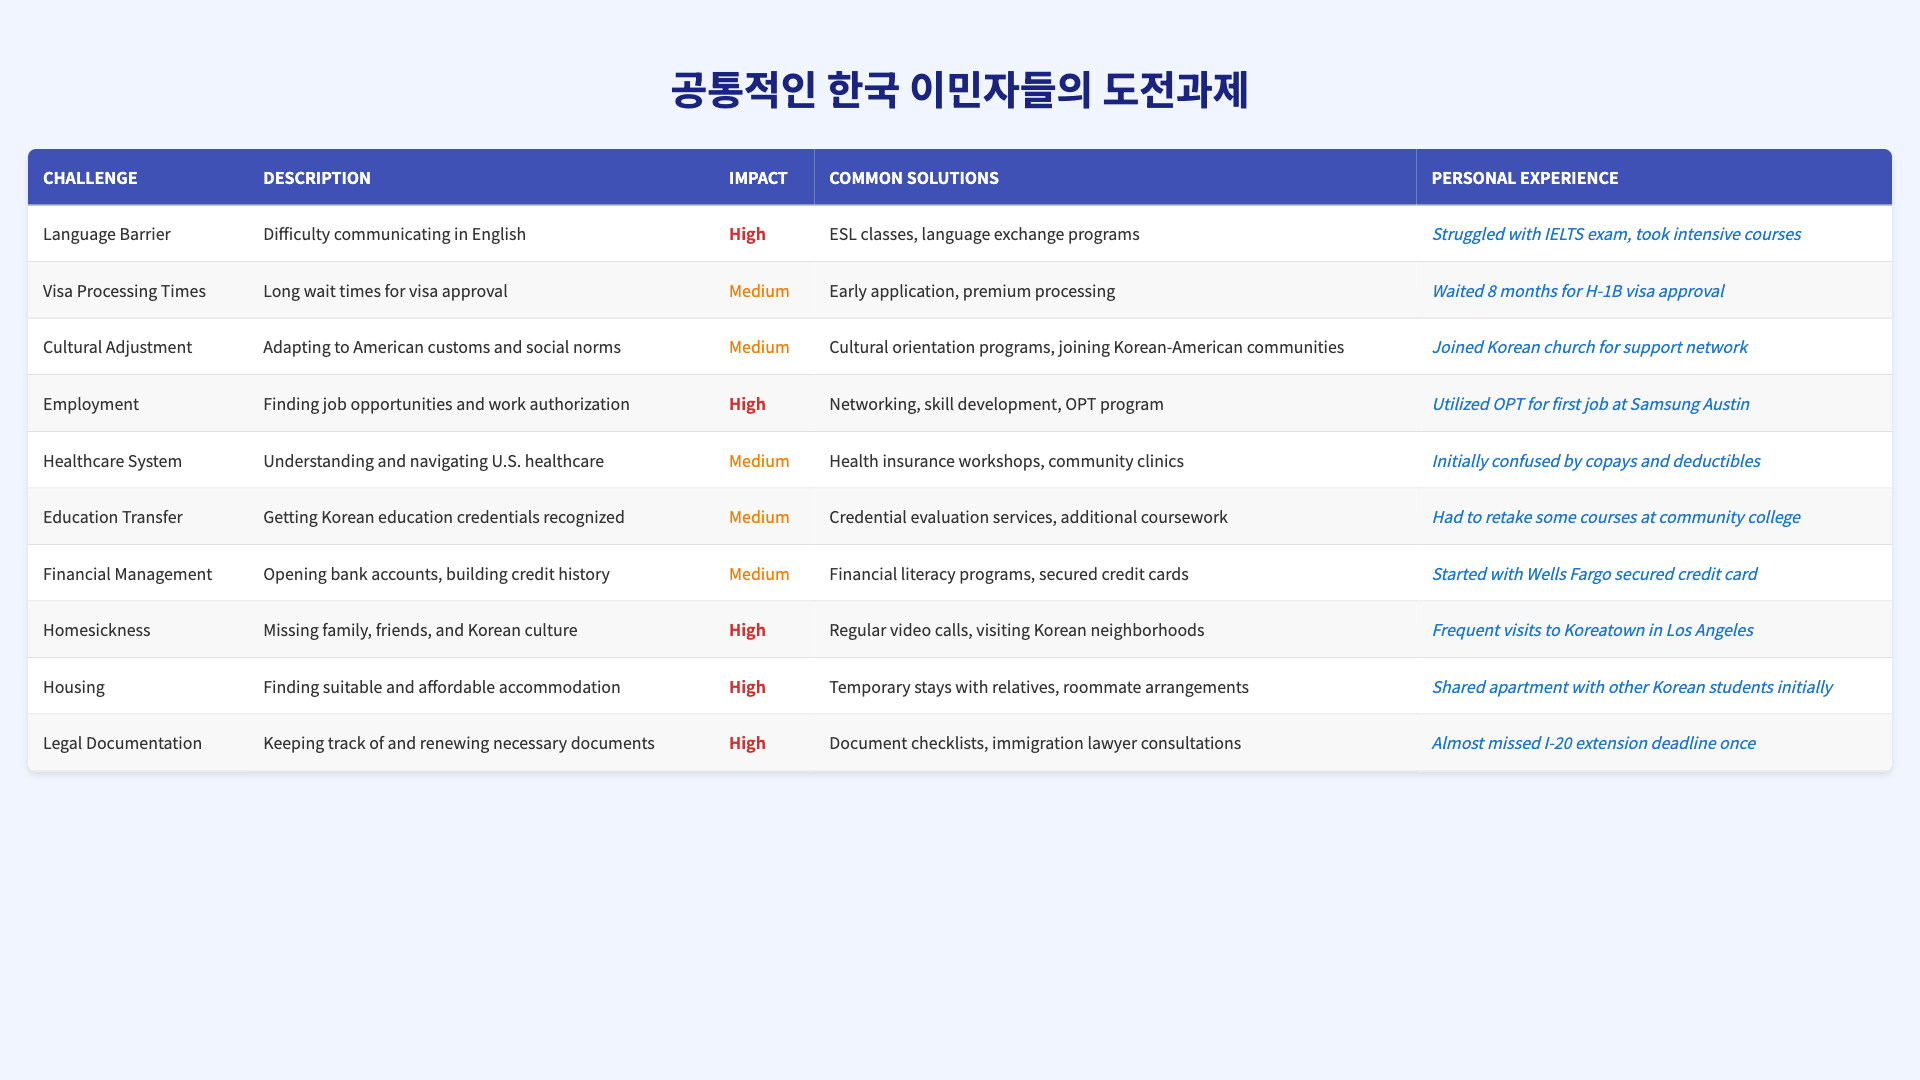What is the challenge with the highest impact? In the table, "Homesickness," "Housing," "Legal Documentation," and "Employment" are marked with "High" impact. Among these, "Homesickness" is mentioned first in the list, but the highest impact could refer to any of them since they are equally categorized.
Answer: Homesickness, Housing, Legal Documentation, and Employment How many challenges are categorized with a medium impact? The table shows that "Visa Processing Times," "Cultural Adjustment," "Healthcare System," "Education Transfer," and "Financial Management" are categorized as having "Medium" impact. There are a total of 5 challenges in this category.
Answer: 5 What common solution is often recommended for finding job opportunities? The common solution for the "Employment" challenge listed in the table is "Networking, skill development, OPT program."
Answer: Networking, skill development, OPT program Is there a challenge related to understanding the U.S. healthcare system? Yes, the table lists "Healthcare System" as a challenge, indicating that immigrants face difficulties in understanding and navigating the U.S. healthcare.
Answer: Yes Which challenge experienced a long wait time for approval? The "Visa Processing Times" challenge is specifically mentioned as having long wait times for visa approval, indicating a significant barrier for immigrants.
Answer: Visa Processing Times What is the description for the challenge regarding cultural adjustment? The description for "Cultural Adjustment" states it involves "Adapting to American customs and social norms," indicating the difficulties immigrants face with cultural integration.
Answer: Adapting to American customs and social norms Which personal experience relates to struggling with healthcare terminology? The personal experience tied to the "Healthcare System" challenge indicates initial confusion by copays and deductibles, reflecting common difficulties immigrants face.
Answer: Initially confused by copays and deductibles Which challenges have the same personal experience of having to take further courses? The "Education Transfer" challenge relates to retaking courses at community college, highlighting the need for recognition of Korean education credentials.
Answer: Education Transfer If a person wanted to combat homesickness, what common solution could they pursue? The table recommends "Regular video calls, visiting Korean neighborhoods" as common solutions to combat homesickness, showing a proactive approach to emotional well-being.
Answer: Regular video calls, visiting Korean neighborhoods How does the personal experience described under "Legal Documentation" reflect the importance of timely applications? The personal experience states they "almost missed I-20 extension deadline," suggesting the critical need for careful attention to document management in the immigration process.
Answer: Critical need for careful attention to document management What are the two main categories where all challenges are focused? The challenges mainly focus on communication (language barrier) and adjustment (cultural, healthcare, and education), indicating the dual nature of barriers faced by immigrants.
Answer: Communication and adjustment 